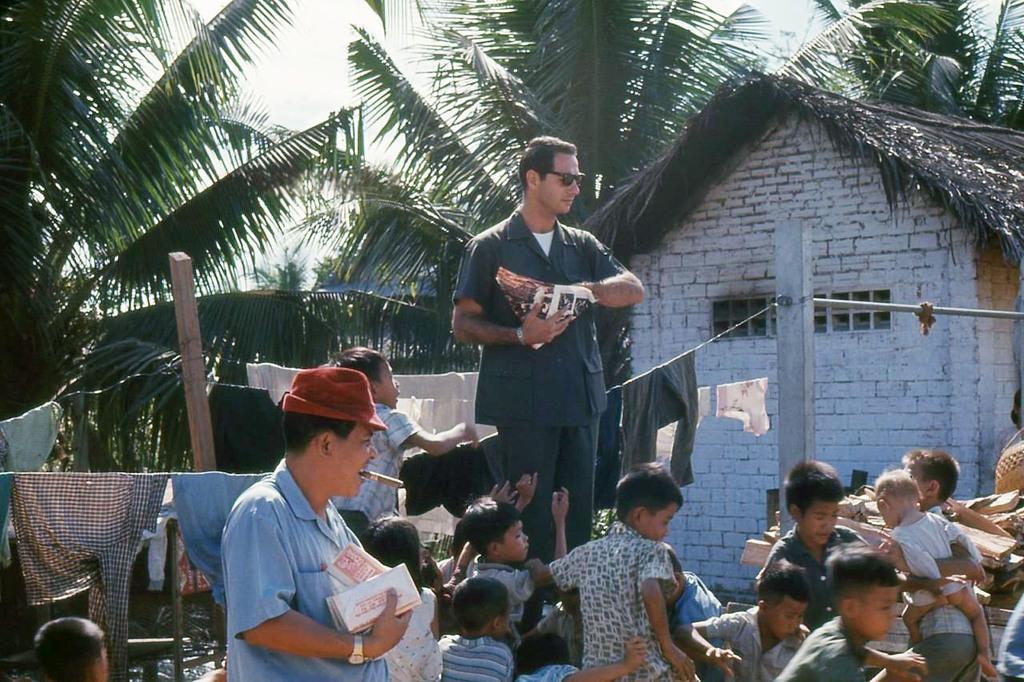In one or two sentences, can you explain what this image depicts? To the right bottom corner of the image there are many kids. In the middle of the image there is a man with a blue shirt, red hat and a cigar in his mouth is standing and holding something in his hand. Behind him there are ropes with clothes on it. In the middle of the image there is a man with black jacket is standing and holding the paper in his hand. In the background to the right side there is a hit with brick wall. And also in the background there are trees. 